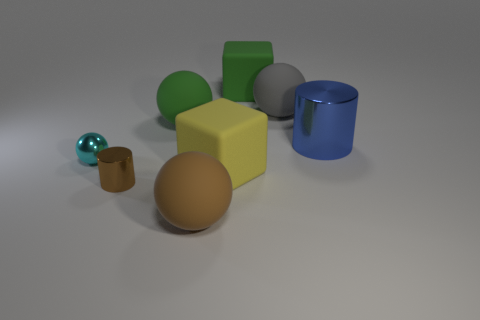Is there any other thing that is the same color as the small metallic sphere?
Ensure brevity in your answer.  No. Is the color of the small shiny ball the same as the large object to the right of the large gray object?
Ensure brevity in your answer.  No. There is a large cube that is behind the blue thing; what number of cubes are behind it?
Give a very brief answer. 0. What shape is the small brown object that is the same material as the large blue thing?
Provide a succinct answer. Cylinder. How many brown objects are small objects or small shiny cylinders?
Provide a short and direct response. 1. There is a matte cube in front of the shiny cylinder that is behind the yellow matte cube; is there a blue shiny object that is in front of it?
Provide a succinct answer. No. Is the number of big cyan matte things less than the number of cyan shiny things?
Give a very brief answer. Yes. Does the shiny object left of the brown shiny object have the same shape as the tiny brown metallic object?
Provide a succinct answer. No. Are any cyan matte blocks visible?
Provide a short and direct response. No. What color is the matte sphere right of the rubber block to the left of the large rubber cube behind the large gray matte thing?
Provide a short and direct response. Gray. 